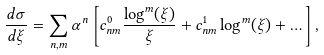<formula> <loc_0><loc_0><loc_500><loc_500>\frac { d \sigma } { d \xi } = \sum _ { n , m } \alpha ^ { n } \left [ c ^ { 0 } _ { n m } \frac { \log ^ { m } ( \xi ) } { \xi } + c ^ { 1 } _ { n m } \log ^ { m } ( \xi ) + \dots \right ] ,</formula> 